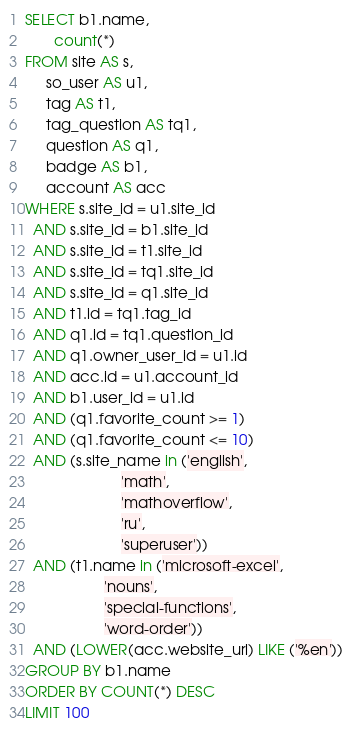Convert code to text. <code><loc_0><loc_0><loc_500><loc_500><_SQL_>SELECT b1.name,
       count(*)
FROM site AS s,
     so_user AS u1,
     tag AS t1,
     tag_question AS tq1,
     question AS q1,
     badge AS b1,
     account AS acc
WHERE s.site_id = u1.site_id
  AND s.site_id = b1.site_id
  AND s.site_id = t1.site_id
  AND s.site_id = tq1.site_id
  AND s.site_id = q1.site_id
  AND t1.id = tq1.tag_id
  AND q1.id = tq1.question_id
  AND q1.owner_user_id = u1.id
  AND acc.id = u1.account_id
  AND b1.user_id = u1.id
  AND (q1.favorite_count >= 1)
  AND (q1.favorite_count <= 10)
  AND (s.site_name in ('english',
                       'math',
                       'mathoverflow',
                       'ru',
                       'superuser'))
  AND (t1.name in ('microsoft-excel',
                   'nouns',
                   'special-functions',
                   'word-order'))
  AND (LOWER(acc.website_url) LIKE ('%en'))
GROUP BY b1.name
ORDER BY COUNT(*) DESC
LIMIT 100</code> 